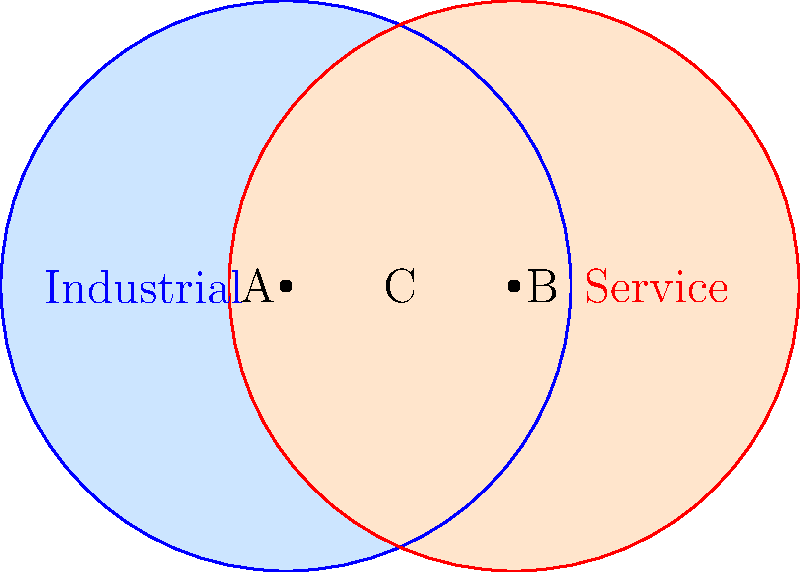In a study of economic sectors, two circular regions represent the industrial and service sectors of a city's economy. The industrial sector is represented by a circle with radius 10 km centered at point A, while the service sector is represented by a circle with radius 10 km centered at point B. If the distance between points A and B is 8 km, what is the area of the overlapping region (labeled C) in square kilometers? Round your answer to two decimal places. To solve this problem, we need to calculate the area of the lens-shaped region formed by the intersection of two circles. We can use the formula for the area of intersection of two circles:

$$ A = 2r^2 \arccos(\frac{d}{2r}) - d\sqrt{r^2 - \frac{d^2}{4}} $$

Where:
$A$ is the area of intersection
$r$ is the radius of both circles
$d$ is the distance between the centers of the circles

Given:
$r = 10$ km
$d = 8$ km

Step 1: Calculate the angle $\theta = \arccos(\frac{d}{2r})$
$$ \theta = \arccos(\frac{8}{2(10)}) = \arccos(0.4) \approx 1.3694 \text{ radians} $$

Step 2: Calculate $\sqrt{r^2 - \frac{d^2}{4}}$
$$ \sqrt{10^2 - \frac{8^2}{4}} = \sqrt{100 - 16} = \sqrt{84} \approx 9.1652 $$

Step 3: Apply the formula
$$ A = 2(10^2)(1.3694) - 8(9.1652) $$
$$ A = 273.88 - 73.3216 $$
$$ A \approx 200.5584 \text{ km}^2 $$

Step 4: Round to two decimal places
$$ A \approx 200.56 \text{ km}^2 $$
Answer: $200.56 \text{ km}^2$ 